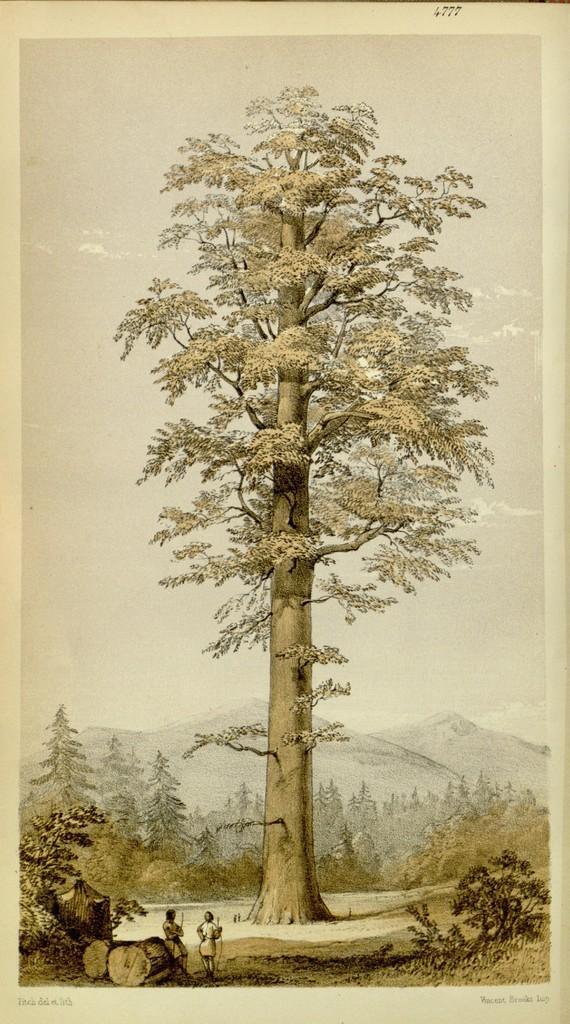Describe this image in one or two sentences. In the foreground of this poster, there are two people standing, few trees and the wooden trunks. In the middle, there is a tree. In the background, there are trees, mountains and the sky. 